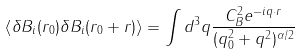Convert formula to latex. <formula><loc_0><loc_0><loc_500><loc_500>\left < \delta B _ { i } ( r _ { 0 } ) \delta B _ { i } ( r _ { 0 } + r ) \right > = \int d ^ { 3 } q \frac { C _ { B } ^ { 2 } e ^ { - i q \cdot r } } { ( q _ { 0 } ^ { 2 } + q ^ { 2 } ) ^ { \alpha / 2 } }</formula> 